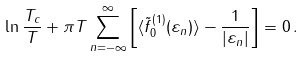<formula> <loc_0><loc_0><loc_500><loc_500>\ln \frac { T _ { c } } { T } + \pi T \sum _ { n = - \infty } ^ { \infty } \left [ \langle \tilde { f } _ { 0 } ^ { ( 1 ) } ( \varepsilon _ { n } ) \rangle - \frac { 1 } { | \varepsilon _ { n } | } \right ] = 0 \, .</formula> 